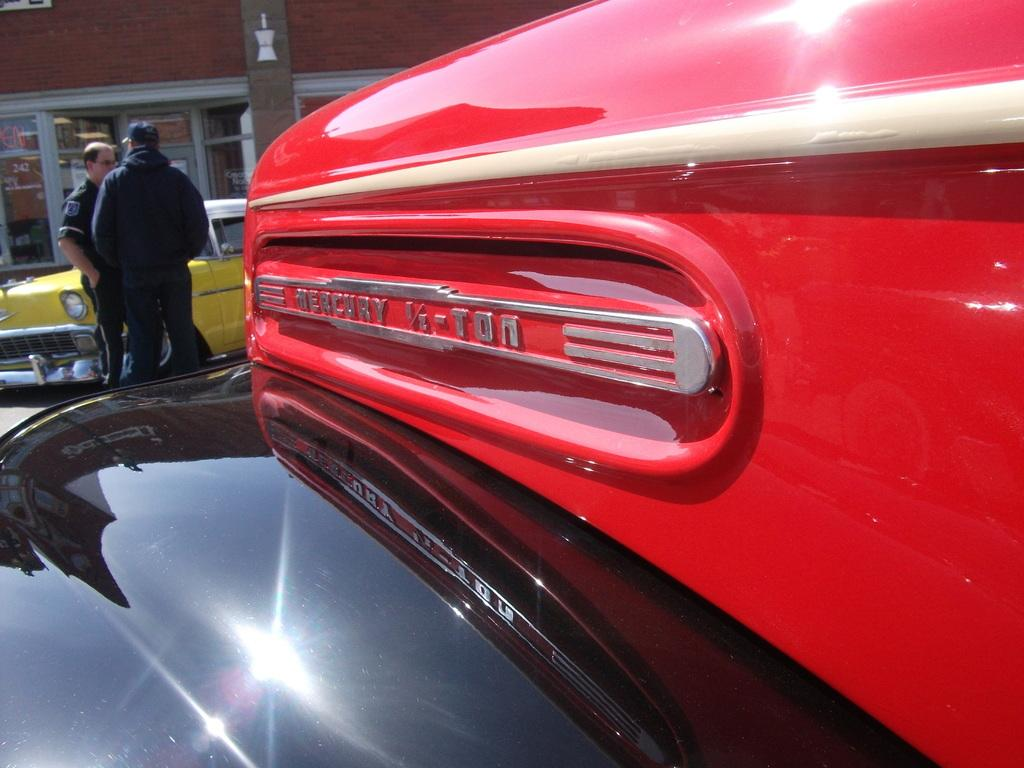Provide a one-sentence caption for the provided image. A side view of an an old red and black mercury truck. 